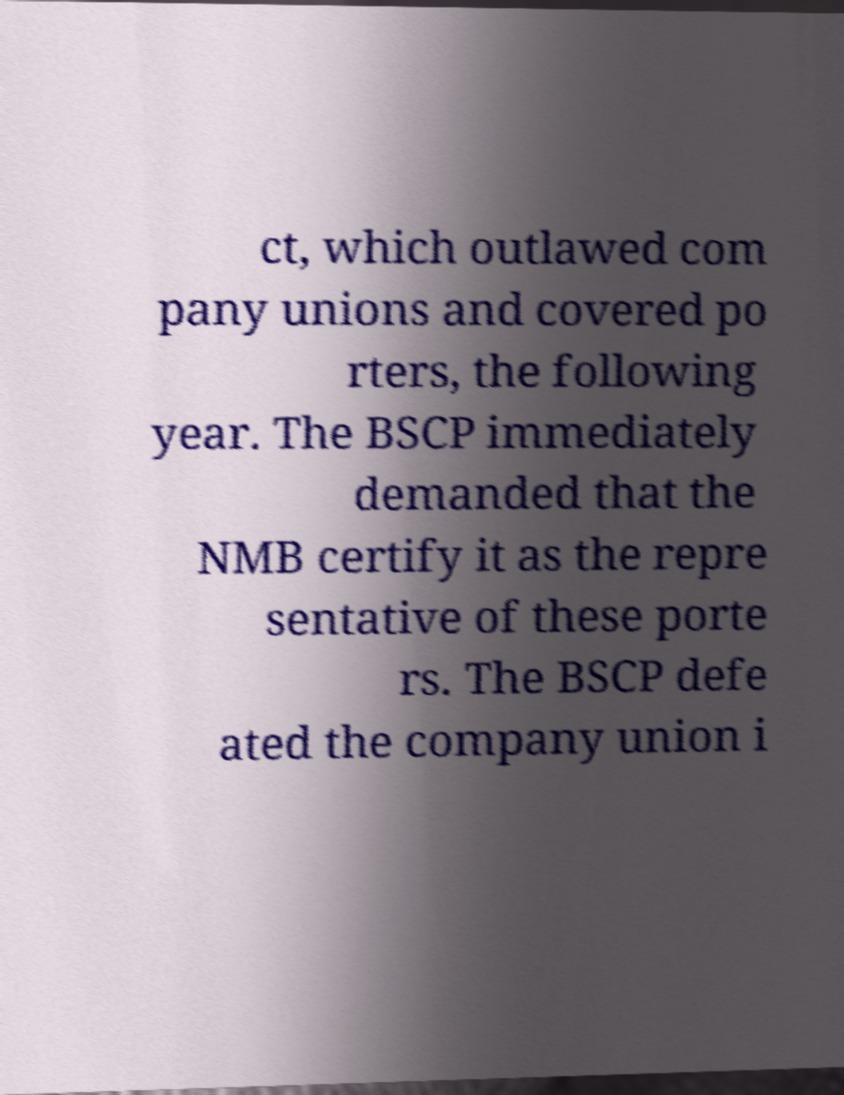Could you extract and type out the text from this image? ct, which outlawed com pany unions and covered po rters, the following year. The BSCP immediately demanded that the NMB certify it as the repre sentative of these porte rs. The BSCP defe ated the company union i 